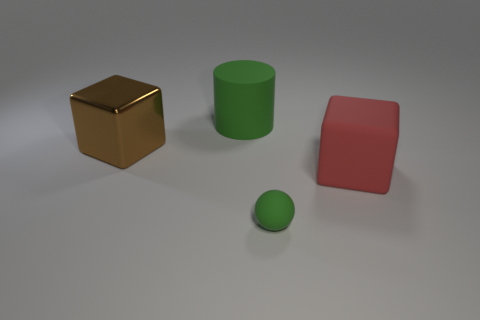Add 1 blue matte blocks. How many objects exist? 5 Subtract all cylinders. How many objects are left? 3 Add 1 red things. How many red things are left? 2 Add 2 small yellow shiny things. How many small yellow shiny things exist? 2 Subtract 0 blue balls. How many objects are left? 4 Subtract all small green shiny balls. Subtract all big green objects. How many objects are left? 3 